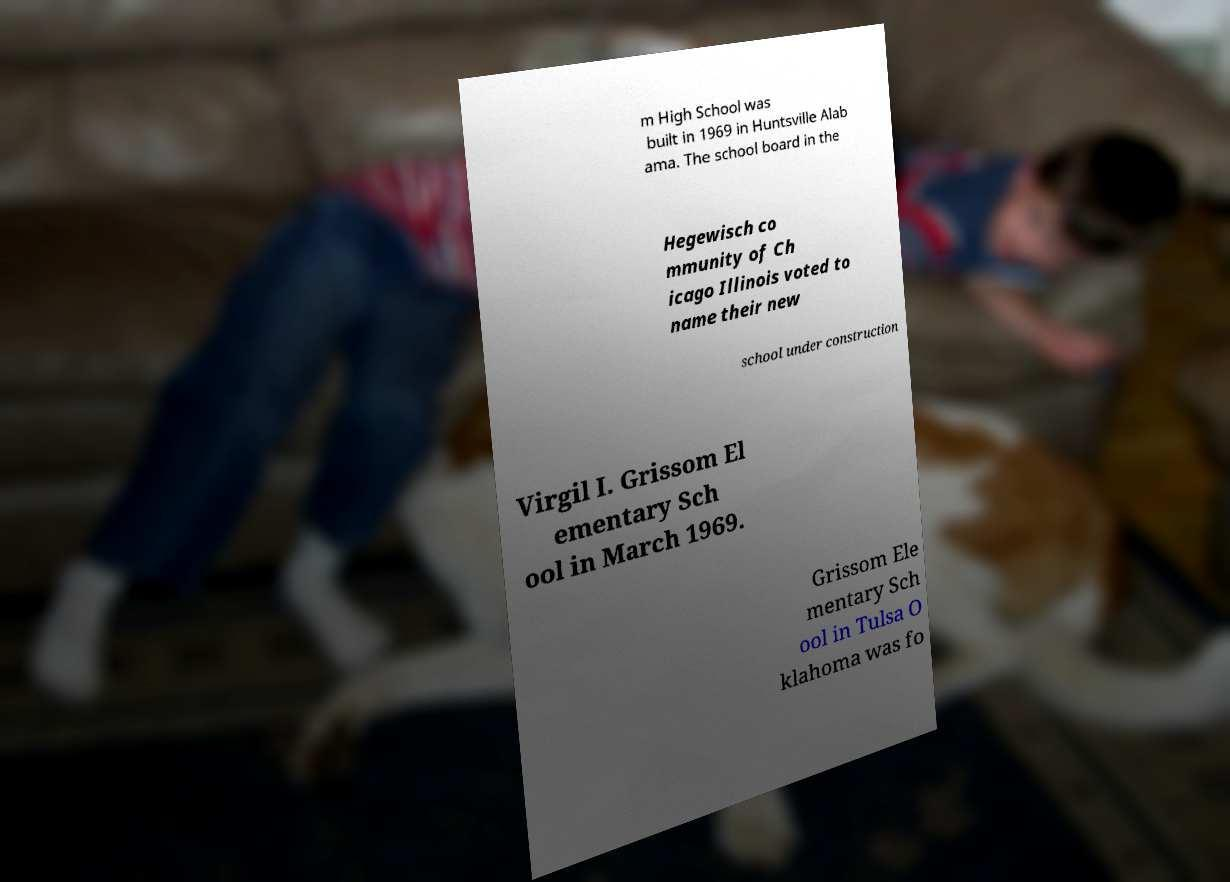Please identify and transcribe the text found in this image. m High School was built in 1969 in Huntsville Alab ama. The school board in the Hegewisch co mmunity of Ch icago Illinois voted to name their new school under construction Virgil I. Grissom El ementary Sch ool in March 1969. Grissom Ele mentary Sch ool in Tulsa O klahoma was fo 